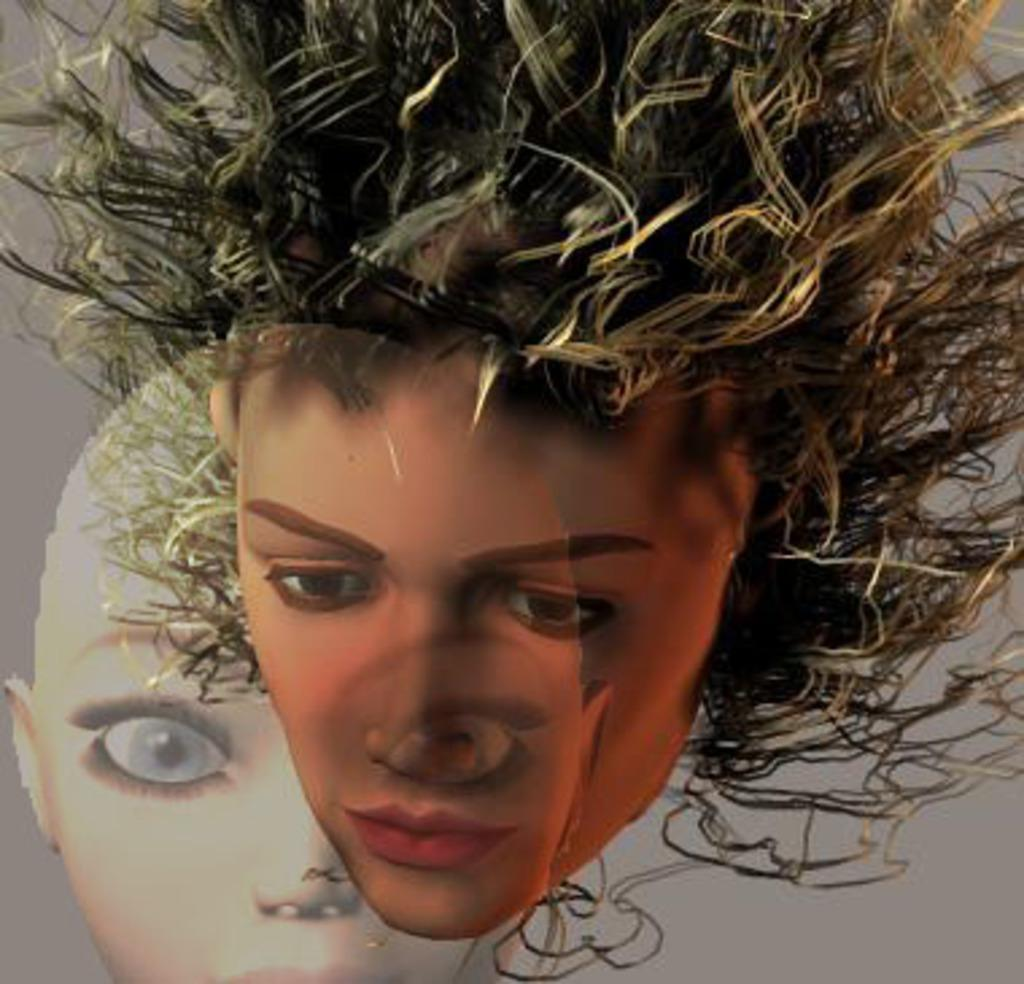What type of image is present in the picture? There is an edited picture in the image. How many faces can be seen in the edited picture? The edited picture contains the faces of two persons. What color is the background of the edited picture? The background of the edited picture is grey. What type of bird can be seen flying in the background of the image? There is no bird present in the image; it only contains an edited picture with a grey background. 